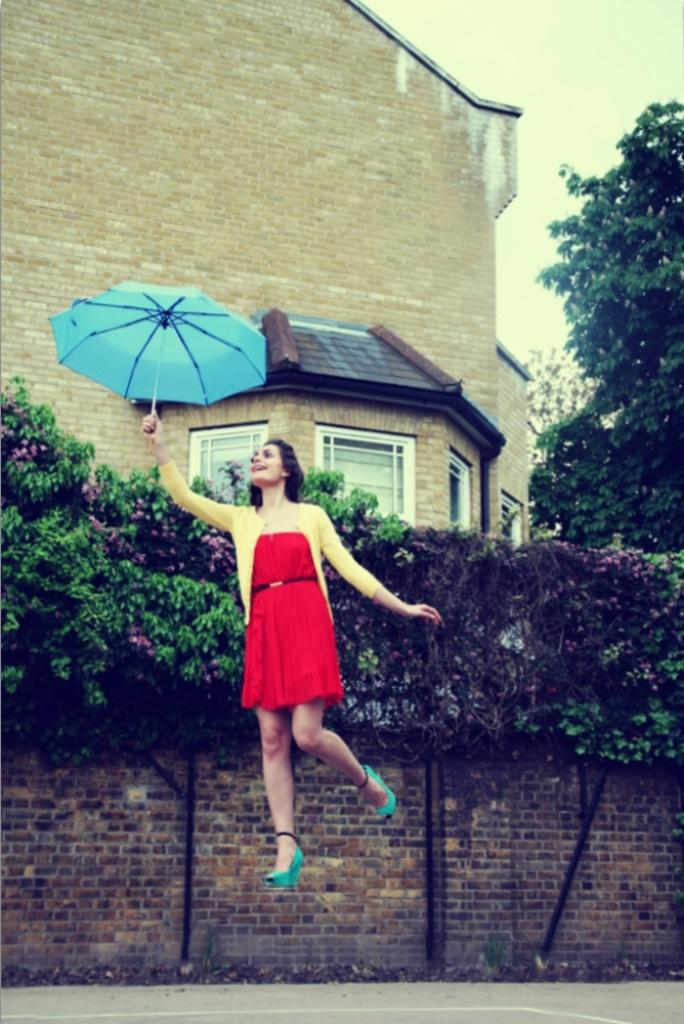Who is the main subject in the image? There is a girl in the center of the image. What is the girl holding in the image? The girl is holding an umbrella. What can be seen in the background of the image? There are trees and a house in the background of the image. How many beds are visible in the image? There are no beds visible in the image. What type of trouble is the girl facing in the image? There is no indication of trouble in the image; the girl is simply holding an umbrella. 